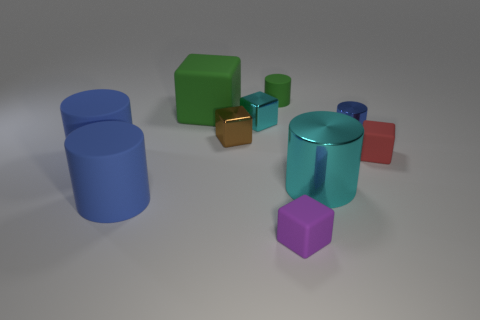There is a cylinder that is the same color as the big matte block; what is its material?
Your response must be concise. Rubber. Is the color of the small cylinder that is right of the tiny green cylinder the same as the cube that is in front of the large cyan thing?
Your answer should be compact. No. Are there any small shiny blocks in front of the brown metallic object?
Your answer should be compact. No. What is the material of the cyan cube?
Your answer should be very brief. Metal. There is a cyan object that is behind the red rubber block; what shape is it?
Your response must be concise. Cube. There is a rubber object that is the same color as the tiny matte cylinder; what size is it?
Your answer should be compact. Large. Is there a brown thing that has the same size as the green cylinder?
Your answer should be compact. Yes. Does the cyan thing that is left of the small green cylinder have the same material as the red block?
Provide a short and direct response. No. Are there an equal number of big cubes that are to the right of the red matte object and big green rubber blocks right of the large metallic cylinder?
Your answer should be compact. Yes. The metallic object that is both on the left side of the tiny purple matte object and right of the brown thing has what shape?
Make the answer very short. Cube. 